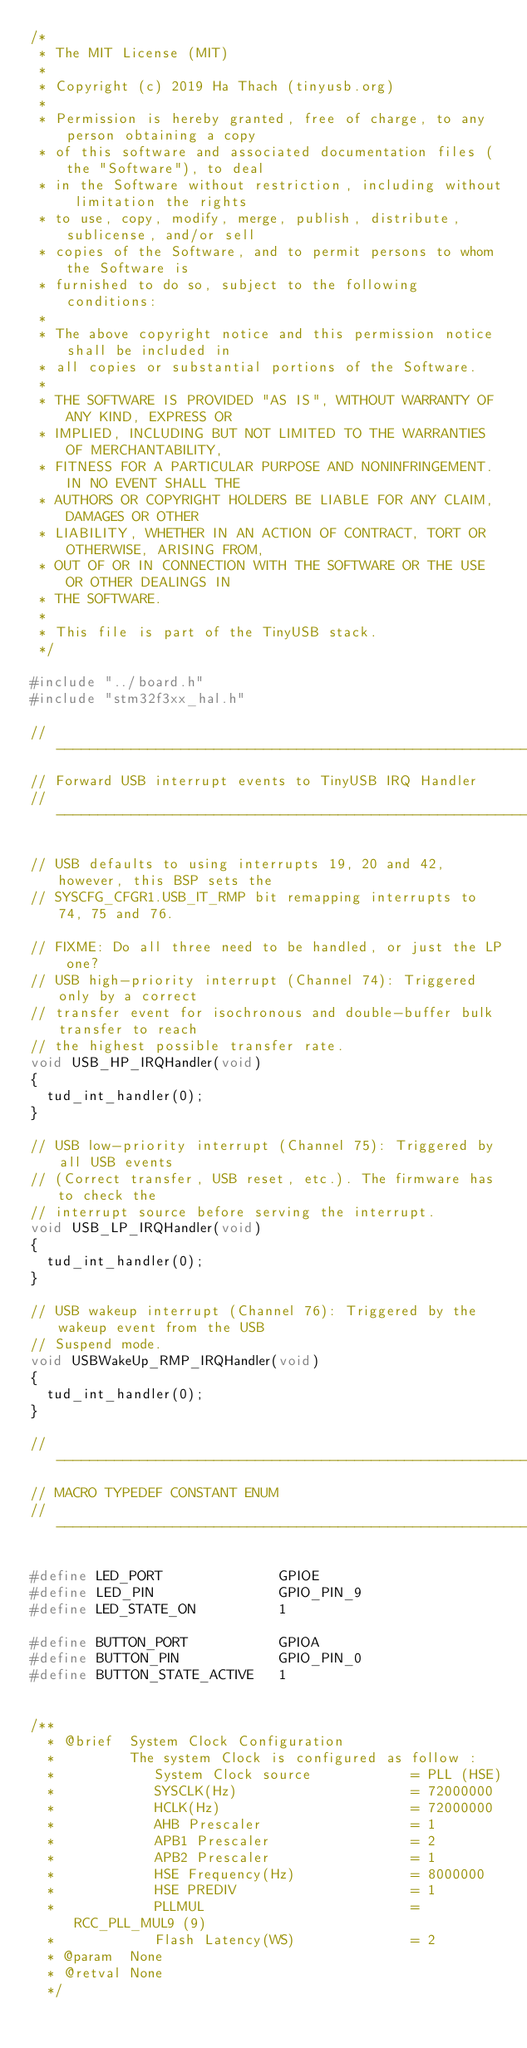Convert code to text. <code><loc_0><loc_0><loc_500><loc_500><_C_>/* 
 * The MIT License (MIT)
 *
 * Copyright (c) 2019 Ha Thach (tinyusb.org)
 *
 * Permission is hereby granted, free of charge, to any person obtaining a copy
 * of this software and associated documentation files (the "Software"), to deal
 * in the Software without restriction, including without limitation the rights
 * to use, copy, modify, merge, publish, distribute, sublicense, and/or sell
 * copies of the Software, and to permit persons to whom the Software is
 * furnished to do so, subject to the following conditions:
 *
 * The above copyright notice and this permission notice shall be included in
 * all copies or substantial portions of the Software.
 *
 * THE SOFTWARE IS PROVIDED "AS IS", WITHOUT WARRANTY OF ANY KIND, EXPRESS OR
 * IMPLIED, INCLUDING BUT NOT LIMITED TO THE WARRANTIES OF MERCHANTABILITY,
 * FITNESS FOR A PARTICULAR PURPOSE AND NONINFRINGEMENT. IN NO EVENT SHALL THE
 * AUTHORS OR COPYRIGHT HOLDERS BE LIABLE FOR ANY CLAIM, DAMAGES OR OTHER
 * LIABILITY, WHETHER IN AN ACTION OF CONTRACT, TORT OR OTHERWISE, ARISING FROM,
 * OUT OF OR IN CONNECTION WITH THE SOFTWARE OR THE USE OR OTHER DEALINGS IN
 * THE SOFTWARE.
 *
 * This file is part of the TinyUSB stack.
 */

#include "../board.h"
#include "stm32f3xx_hal.h"

//--------------------------------------------------------------------+
// Forward USB interrupt events to TinyUSB IRQ Handler
//--------------------------------------------------------------------+

// USB defaults to using interrupts 19, 20 and 42, however, this BSP sets the
// SYSCFG_CFGR1.USB_IT_RMP bit remapping interrupts to 74, 75 and 76.

// FIXME: Do all three need to be handled, or just the LP one?
// USB high-priority interrupt (Channel 74): Triggered only by a correct
// transfer event for isochronous and double-buffer bulk transfer to reach
// the highest possible transfer rate.
void USB_HP_IRQHandler(void)
{
  tud_int_handler(0);
}

// USB low-priority interrupt (Channel 75): Triggered by all USB events
// (Correct transfer, USB reset, etc.). The firmware has to check the
// interrupt source before serving the interrupt.
void USB_LP_IRQHandler(void)
{
  tud_int_handler(0);
}

// USB wakeup interrupt (Channel 76): Triggered by the wakeup event from the USB
// Suspend mode.
void USBWakeUp_RMP_IRQHandler(void)
{
  tud_int_handler(0);
}

//--------------------------------------------------------------------+
// MACRO TYPEDEF CONSTANT ENUM
//--------------------------------------------------------------------+

#define LED_PORT              GPIOE
#define LED_PIN               GPIO_PIN_9
#define LED_STATE_ON          1

#define BUTTON_PORT           GPIOA
#define BUTTON_PIN            GPIO_PIN_0
#define BUTTON_STATE_ACTIVE   1


/**
  * @brief  System Clock Configuration
  *         The system Clock is configured as follow :
  *            System Clock source            = PLL (HSE)
  *            SYSCLK(Hz)                     = 72000000
  *            HCLK(Hz)                       = 72000000
  *            AHB Prescaler                  = 1
  *            APB1 Prescaler                 = 2
  *            APB2 Prescaler                 = 1
  *            HSE Frequency(Hz)              = 8000000
  *            HSE PREDIV                     = 1
  *            PLLMUL                         = RCC_PLL_MUL9 (9)
  *            Flash Latency(WS)              = 2
  * @param  None
  * @retval None
  */</code> 